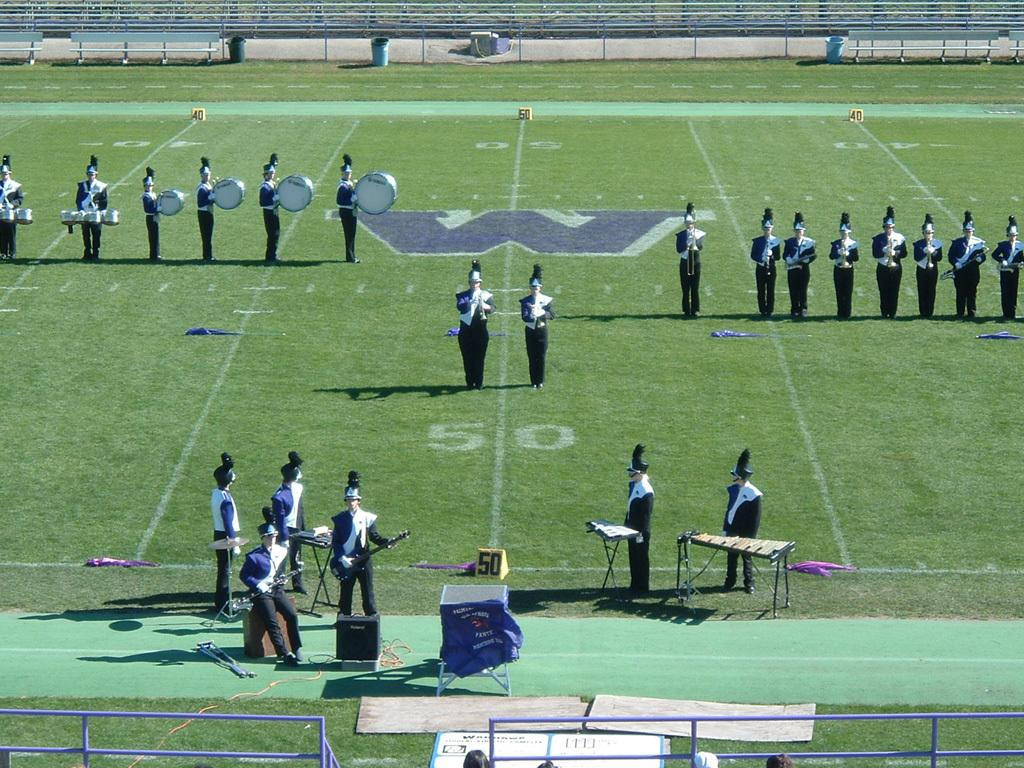<image>
Create a compact narrative representing the image presented. Two members of the band flank the 50 yard line of the football field. 